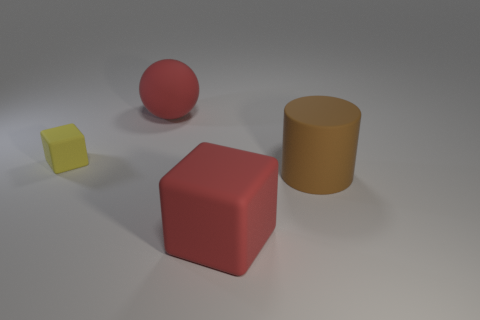Can you describe the colors and shapes of the blocks present in the image? Certainly. In the image, there are three distinct blocks, each with its own unique color and shape. There is a large red cube, a smaller yellow cube, and a sizable cylindrical block that has a matte orange hue. 